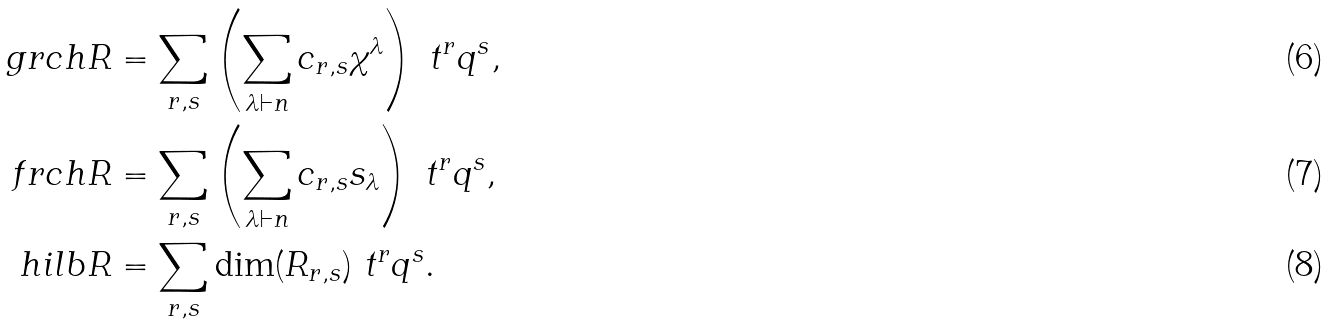Convert formula to latex. <formula><loc_0><loc_0><loc_500><loc_500>\ g r c h { R } & = \sum _ { r , s } \left ( \sum _ { \lambda \vdash n } c _ { r , s } \chi ^ { \lambda } \right ) \ t ^ { r } q ^ { s } , \\ \ f r c h { R } & = \sum _ { r , s } \left ( \sum _ { \lambda \vdash n } c _ { r , s } s _ { \lambda } \right ) \ t ^ { r } q ^ { s } , \\ \ h i l b { R } & = \sum _ { r , s } \dim ( R _ { r , s } ) \ t ^ { r } q ^ { s } .</formula> 